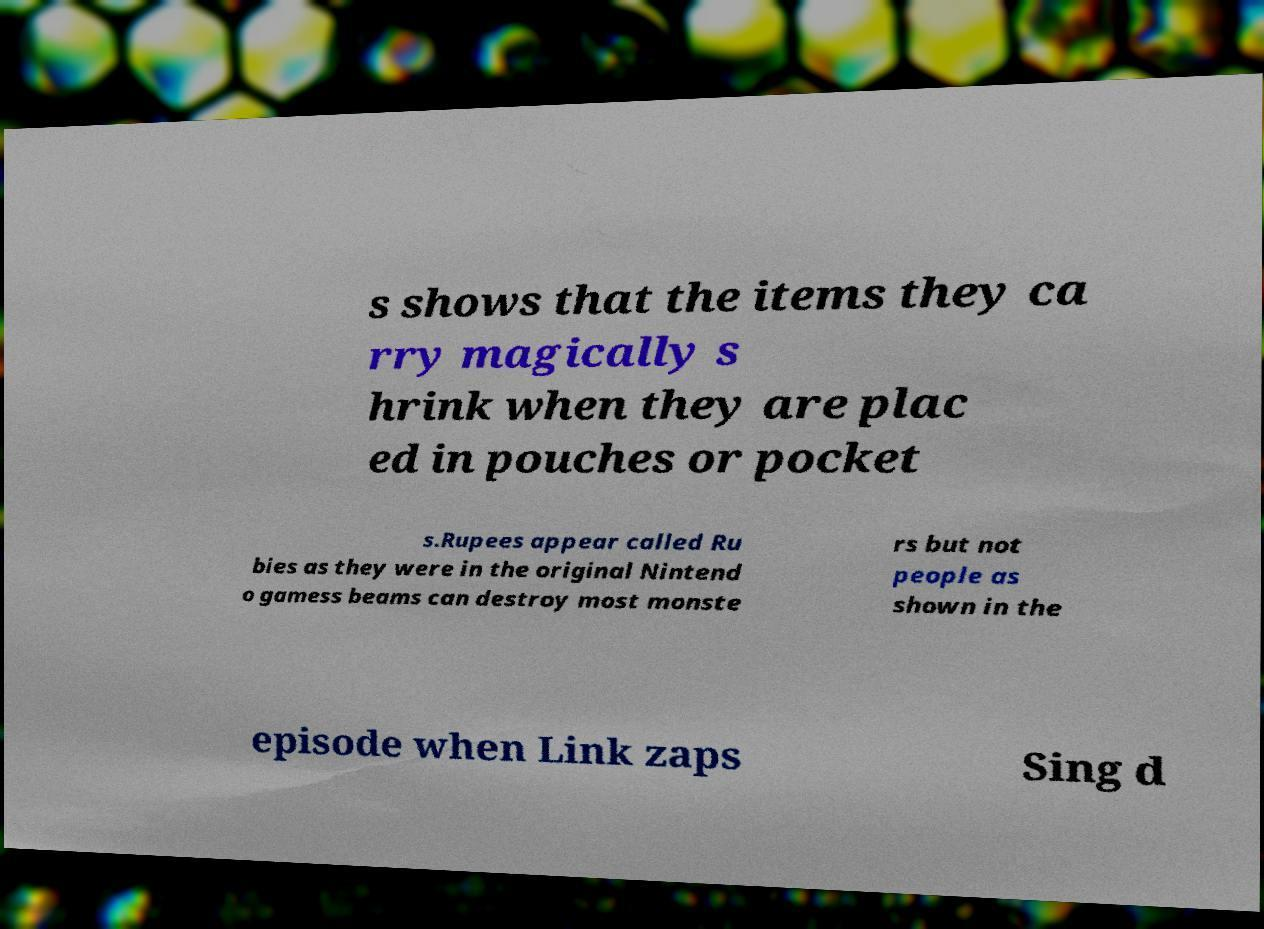What messages or text are displayed in this image? I need them in a readable, typed format. s shows that the items they ca rry magically s hrink when they are plac ed in pouches or pocket s.Rupees appear called Ru bies as they were in the original Nintend o gamess beams can destroy most monste rs but not people as shown in the episode when Link zaps Sing d 